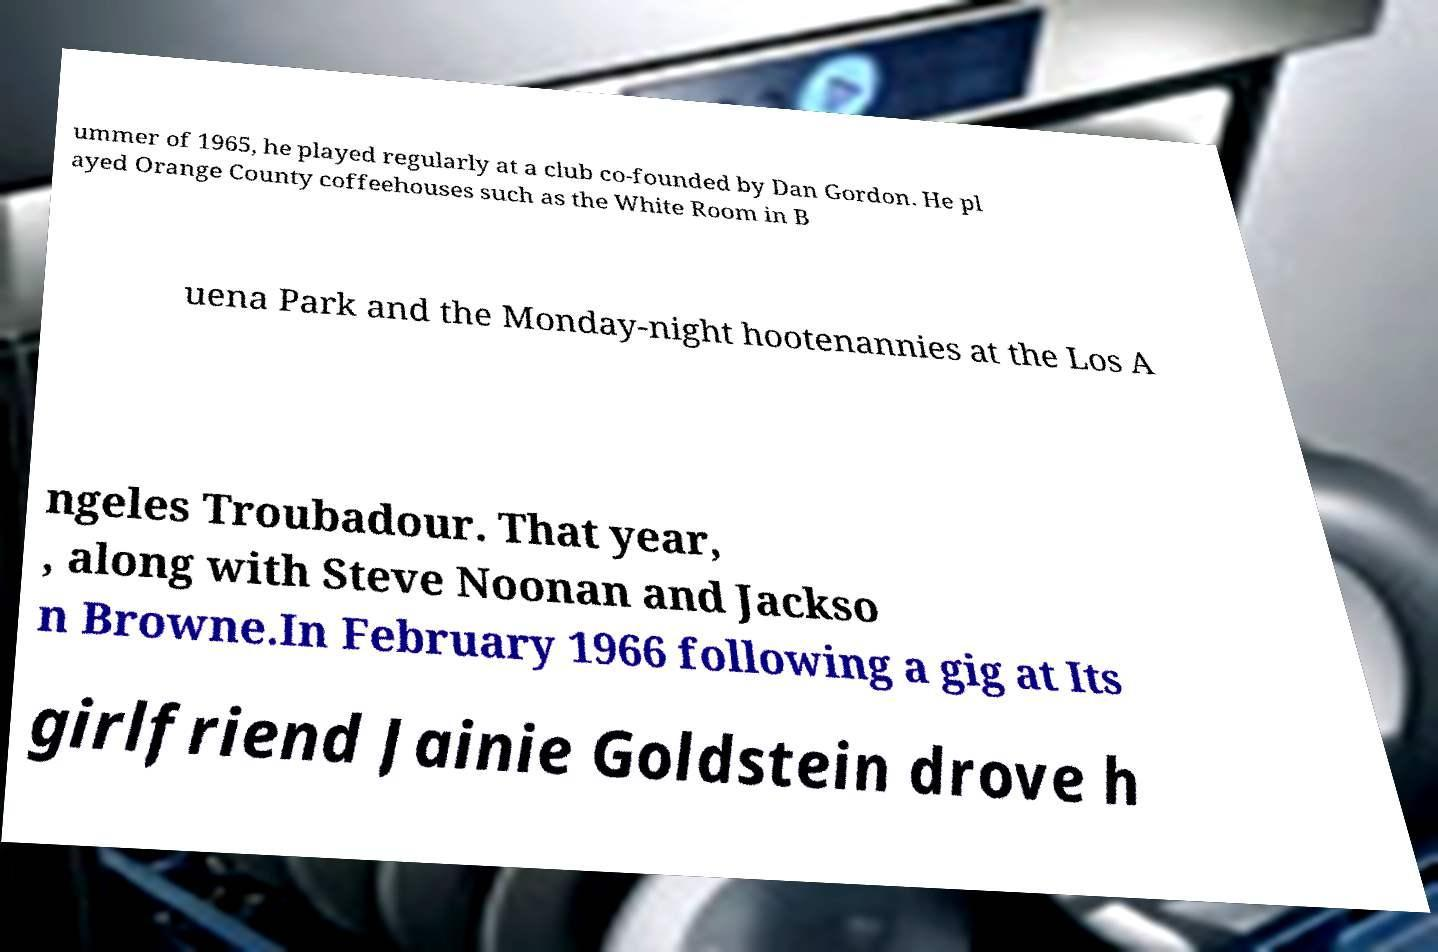What messages or text are displayed in this image? I need them in a readable, typed format. ummer of 1965, he played regularly at a club co-founded by Dan Gordon. He pl ayed Orange County coffeehouses such as the White Room in B uena Park and the Monday-night hootenannies at the Los A ngeles Troubadour. That year, , along with Steve Noonan and Jackso n Browne.In February 1966 following a gig at Its girlfriend Jainie Goldstein drove h 